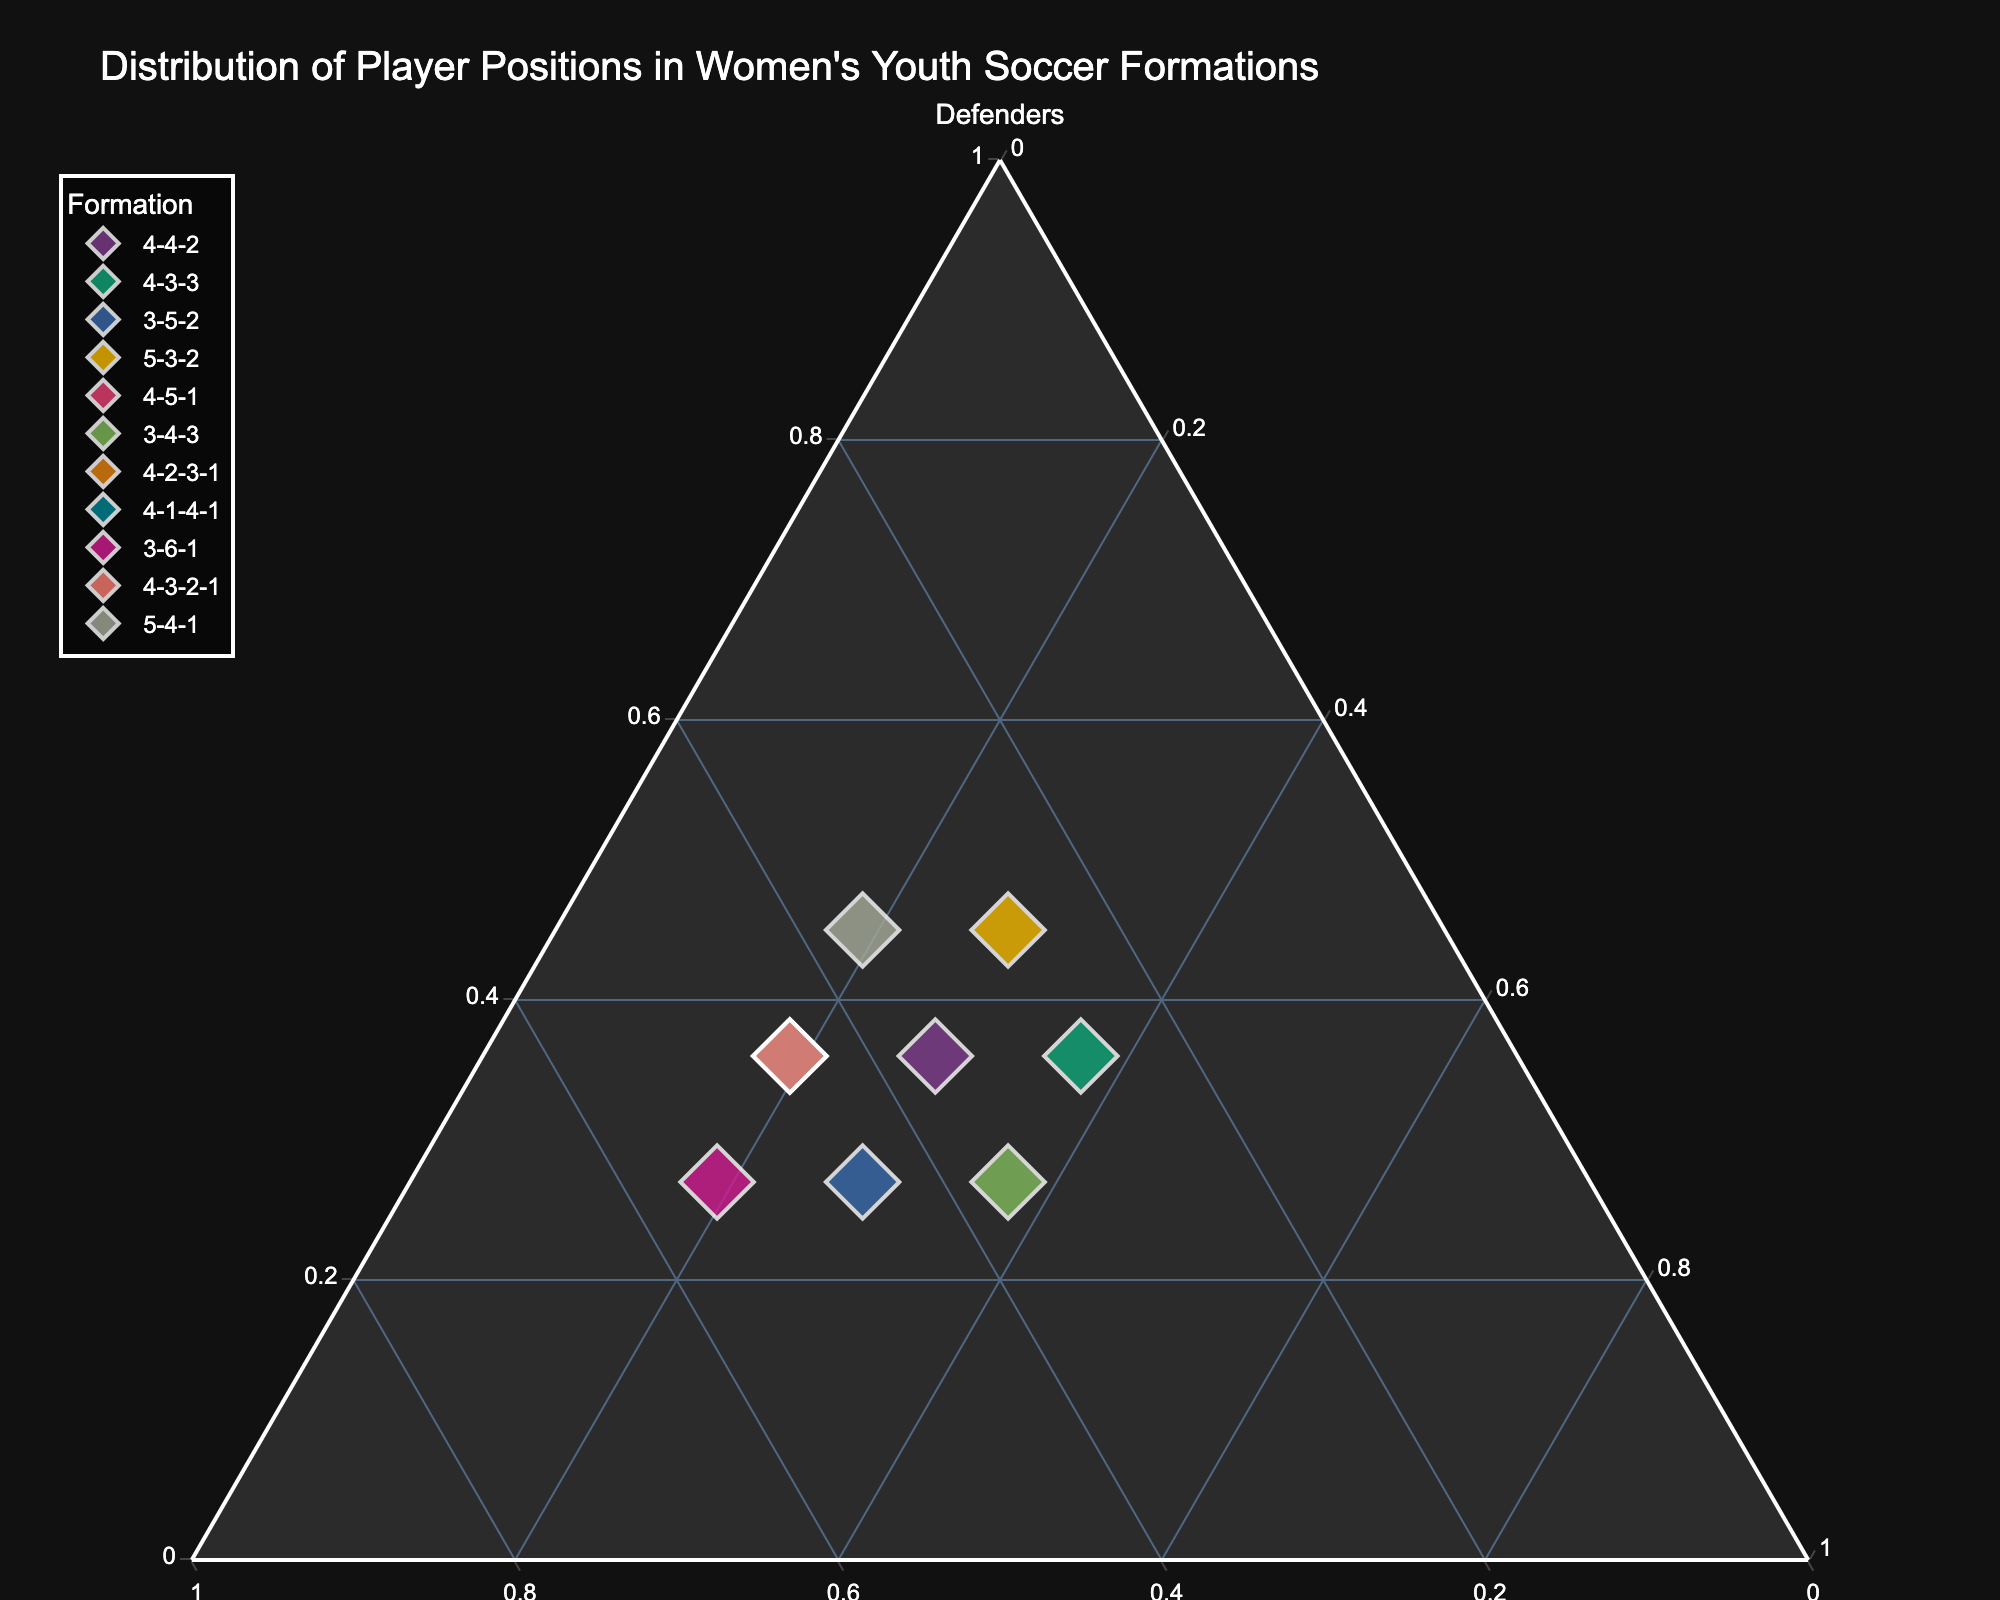How many formations have 36% defenders? To find this, look for the points along the "Defenders" axis with a value of 0.36. The formations are 4-4-2, 4-3-3, 4-5-1, 4-2-3-1, 4-1-4-1, and 4-3-2-1. Therefore, there are 6 formations.
Answer: 6 Which formation has the highest proportion of midfielders? Compare the "Midfielders" values across all formations. The highest proportion is 0.54, which corresponds to the 3-6-1 formation.
Answer: 3-6-1 What is the difference in the percentage of forwards between 4-3-3 and 4-1-4-1 formations? The percentage of forwards in the 4-3-3 formation is 37%, and in the 4-1-4-1 formation, it is 19%. The difference is 37% - 19% = 18%.
Answer: 18% Does any formation have an equal distribution of all three positions? An equal distribution would mean all three proportions are the same. In the data, no formation has defenders, midfielders, and forwards with the same proportion.
Answer: No Which formations allocate 45% to midfielders? Identify formations with "Midfielders" values of 0.45. These are the 3-5-2, 4-5-1, 4-2-3-1, 4-1-4-1, and 4-3-2-1 formations.
Answer: 3-5-2, 4-5-1, 4-2-3-1, 4-1-4-1, 4-3-2-1 Which two formations share the same distribution between defenders and forwards but differ in midfielders? 4-4-2 and 3-5-2 both allocate 36% to defenders and 28% to forwards, but they differ in midfielders: 36% for 4-4-2 and 45% for 3-5-2.
Answer: 4-4-2 and 3-5-2 Which formation has the lowest percentage of forwards? Compare the "Forwards" values and find the lowest, which is 19%. This corresponds to the 4-5-1, 4-2-3-1, 4-1-4-1, and 3-6-1 formations.
Answer: 4-5-1, 4-2-3-1, 4-1-4-1, 3-6-1 